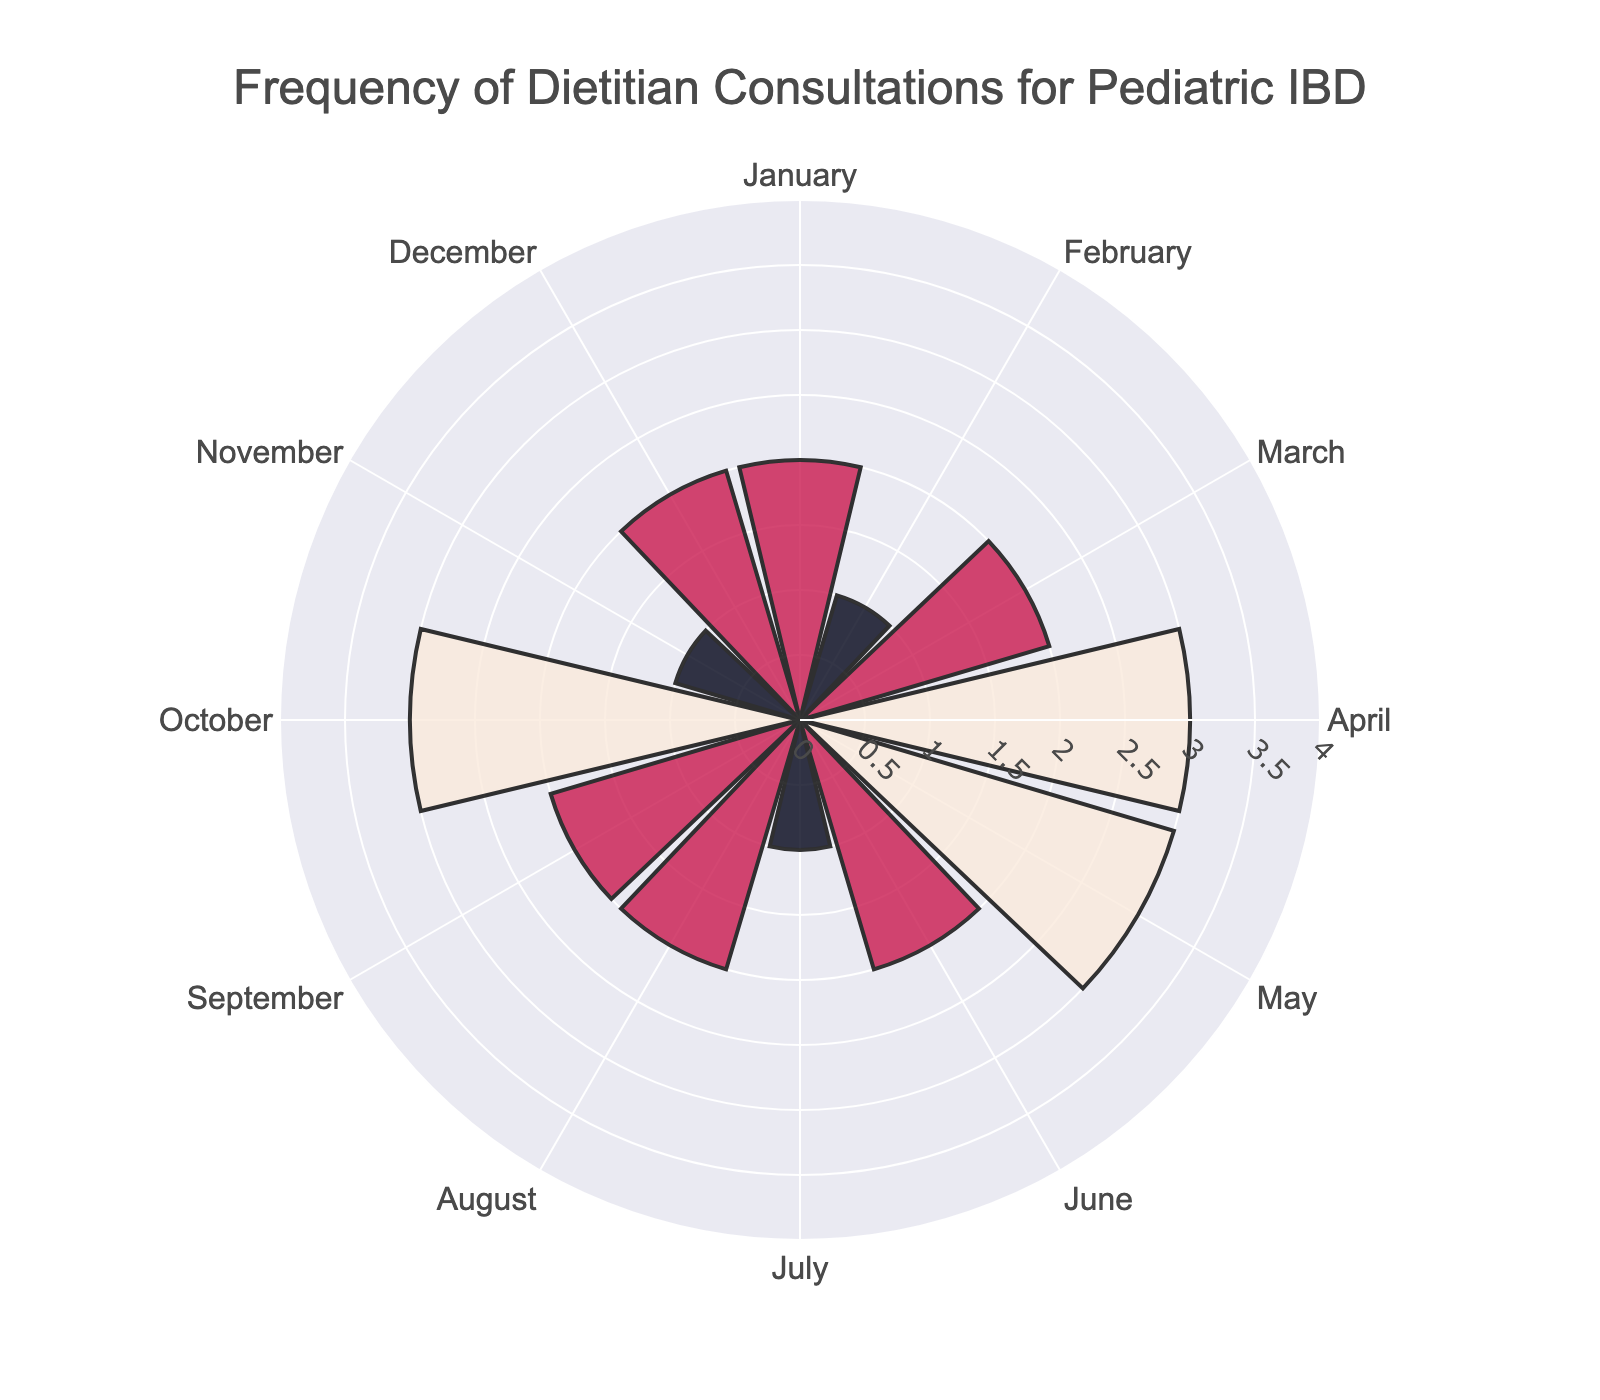What's the title of the figure? The title is displayed at the top center of the figure in a prominent font-size. It reads "Frequency of Dietitian Consultations for Pediatric IBD".
Answer: Frequency of Dietitian Consultations for Pediatric IBD How many consultations occurred in April? Locate the bar labeled "April" on the rose chart and observe its radius length. The count of consultations is shown by the radial length, and the value is 3.
Answer: 3 Which month had the lowest number of consultations? Identify the shortest bars in the rose chart and read the corresponding months. The months with the shortest bars are February, July, and November, each with 1 consultation.
Answer: February, July, and November What's the total number of consultations for the first quarter of the year? Sum the consultations from January, February, and March. The values are 2, 1, and 2 respectively. So, 2 + 1 + 2 = 5 consultations.
Answer: 5 Which months had an equal number of consultations? Compare the radial lengths and count values for different months. January, March, June, August, September, and December each had 2 consultations. April, May, and October each had 3 consultations. February, July, and November had 1 consultation each.
Answer: January-March-June-August-September-December and April-May-October How many months had more than 2 consultations? Identify bars with radial lengths greater than 2. The months April, May, and October had more than 2 consultations.
Answer: 3 What's the average number of consultations per month? Calculate the sum of consultations for all months, which is 24. Then divide by the number of months (12). So, 24/12 = 2 consultations per month on average.
Answer: 2 In which month did the highest number of consultations take place? Find the longest bars on the rose chart, which indicate the highest number of consultations. April, May, and October each had the longest bars with 3 consultations each.
Answer: April, May, and October What's the difference in the number of consultations between April and July? April had 3 consultations and July had 1 consultation. The difference is 3 - 1 = 2.
Answer: 2 Is there a pattern in the number of consultations over the year? Analyzing the variations month by month, the consultations fluctuate rather than follow a strict increasing or decreasing pattern. Whereas some months show higher (3) or lower (1) consultations, many have 2 as the most frequent count.
Answer: Fluctuating pattern 